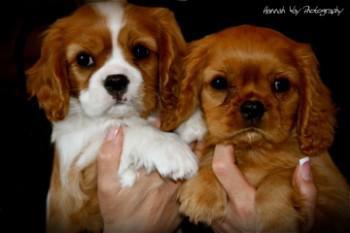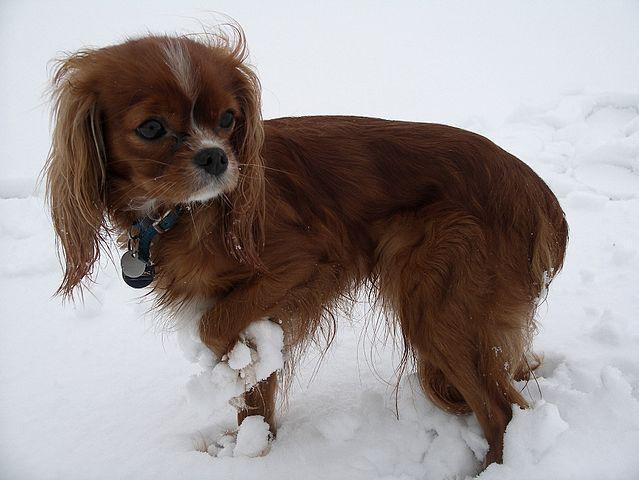The first image is the image on the left, the second image is the image on the right. Evaluate the accuracy of this statement regarding the images: "There are no more than three dogs.". Is it true? Answer yes or no. Yes. The first image is the image on the left, the second image is the image on the right. Assess this claim about the two images: "There are no more than three dogs.". Correct or not? Answer yes or no. Yes. 